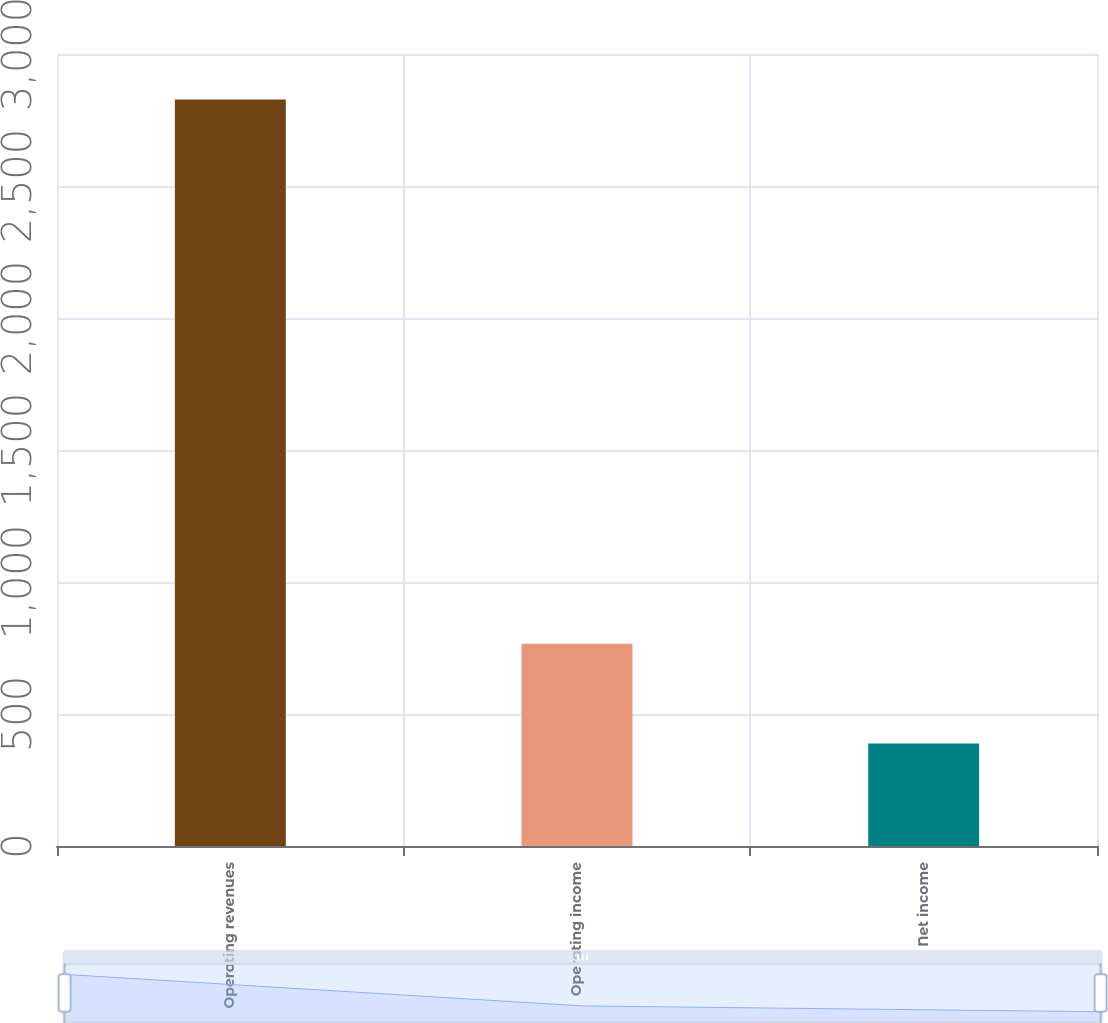Convert chart. <chart><loc_0><loc_0><loc_500><loc_500><bar_chart><fcel>Operating revenues<fcel>Operating income<fcel>Net income<nl><fcel>2828<fcel>766<fcel>388<nl></chart> 